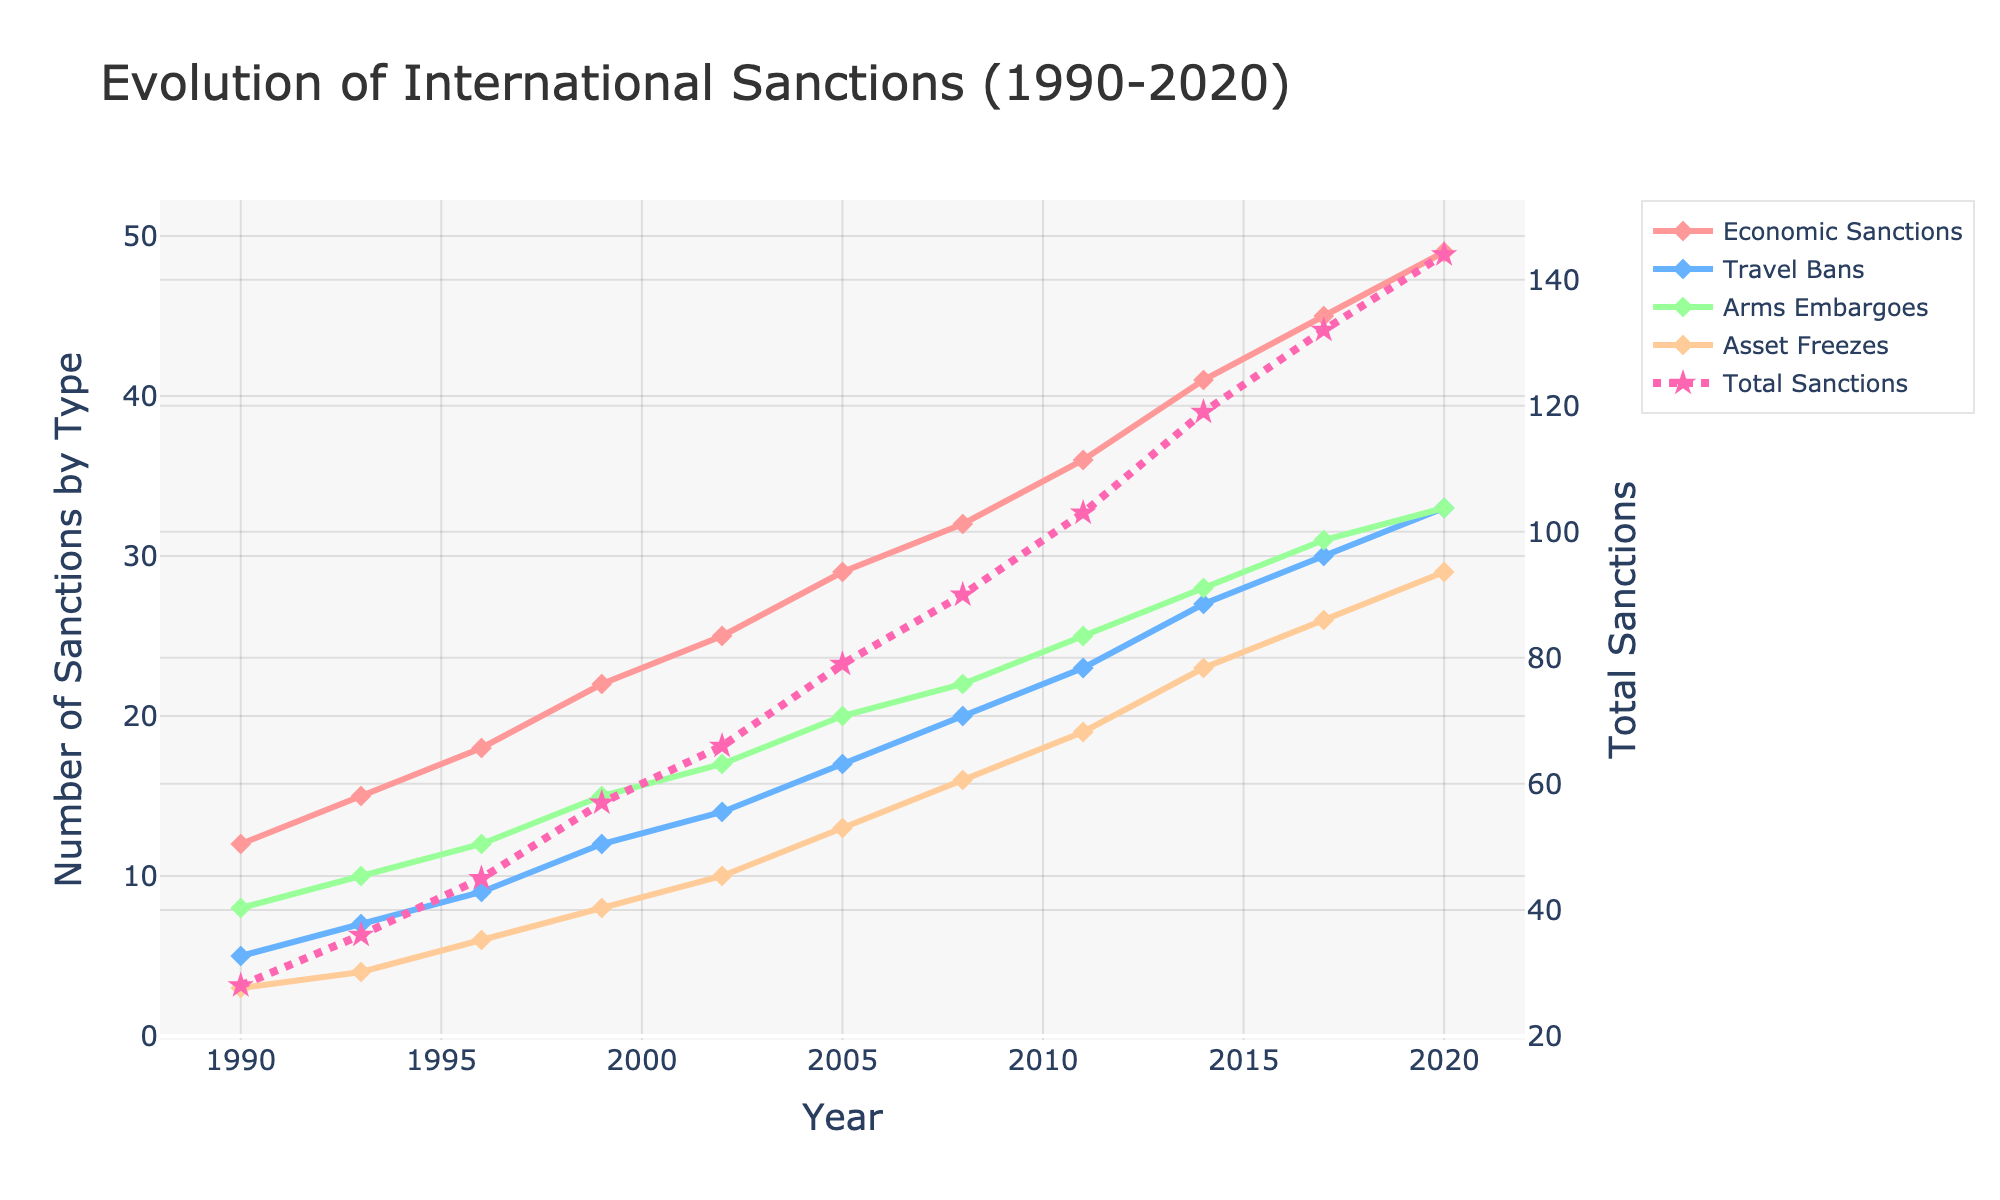What kind of trend do you observe for Economic Sanctions between 1990 and 2020? The line representing Economic Sanctions shows a steady increase from 12 in 1990 to 49 in 2020. The upward trend indicates a consistent rise in the imposition of Economic Sanctions over the years.
Answer: A steady increase Which type of sanction had the highest increase in absolute numbers between 1990 and 2020? To determine this, compare the differences in the number of each type of sanction between these years. Economic Sanctions increased from 12 to 49 (an increase of 37), Travel Bans from 5 to 33 (an increase of 28), Arms Embargoes from 8 to 33 (an increase of 25), and Asset Freezes from 3 to 29 (an increase of 26). Economic Sanctions had the highest increase.
Answer: Economic Sanctions What is the overall trend of Total Sanctions from 1990 to 2020, and what does it suggest? The line for Total Sanctions exhibits a clear upward trajectory, rising from 28 in 1990 to 144 in 2020. This suggests a significant and continuous increase in the number of total sanctions imposed over the past three decades.
Answer: Continuous increase In which year did Arms Embargoes first surpass the count of 20? Observing the line representing Arms Embargoes, it first surpasses the count of 20 in the year 2008.
Answer: 2008 Which type of sanction experienced the least growth from 1990 to 2020? To find out the least growth, compare the difference in sanctions across the years. Asset Freezes grew from 3 to 29 (an increase of 26), which is less than other categories. Economic Sanctions increased by 37, Travel Bans by 28, and Arms Embargoes by 25. Asset Freezes had the least growth.
Answer: Asset Freezes How many Total Sanctions were imposed in 2005 compared to 2014, and what is the percentage increase? In 2005, the Total Sanctions were 79, and in 2014, they were 119. The percentage increase can be calculated as ((119-79) / 79) * 100 = 50.63%.
Answer: 50.63% What visual attribute is used to differentiate the Total Sanctions line from other sanction types? The Total Sanctions line is differentiated by its unique line style, which is dashed, and has a distinct star-shaped marker.
Answer: Dashed line with star markers Did Travel Bans ever exceed Economic Sanctions in any year? By comparing the respective lines for each year, Travel Bans never exceeded Economic Sanctions at any point from 1990 to 2020.
Answer: No Was the increase in the number of sanctions (any type) uniform over the years, or were there years with sudden jumps? Observing the trend lines, the increase does not appear to be uniform; there are years with sudden jumps, notably around the mid-1990s and post-2010.
Answer: Not uniform 